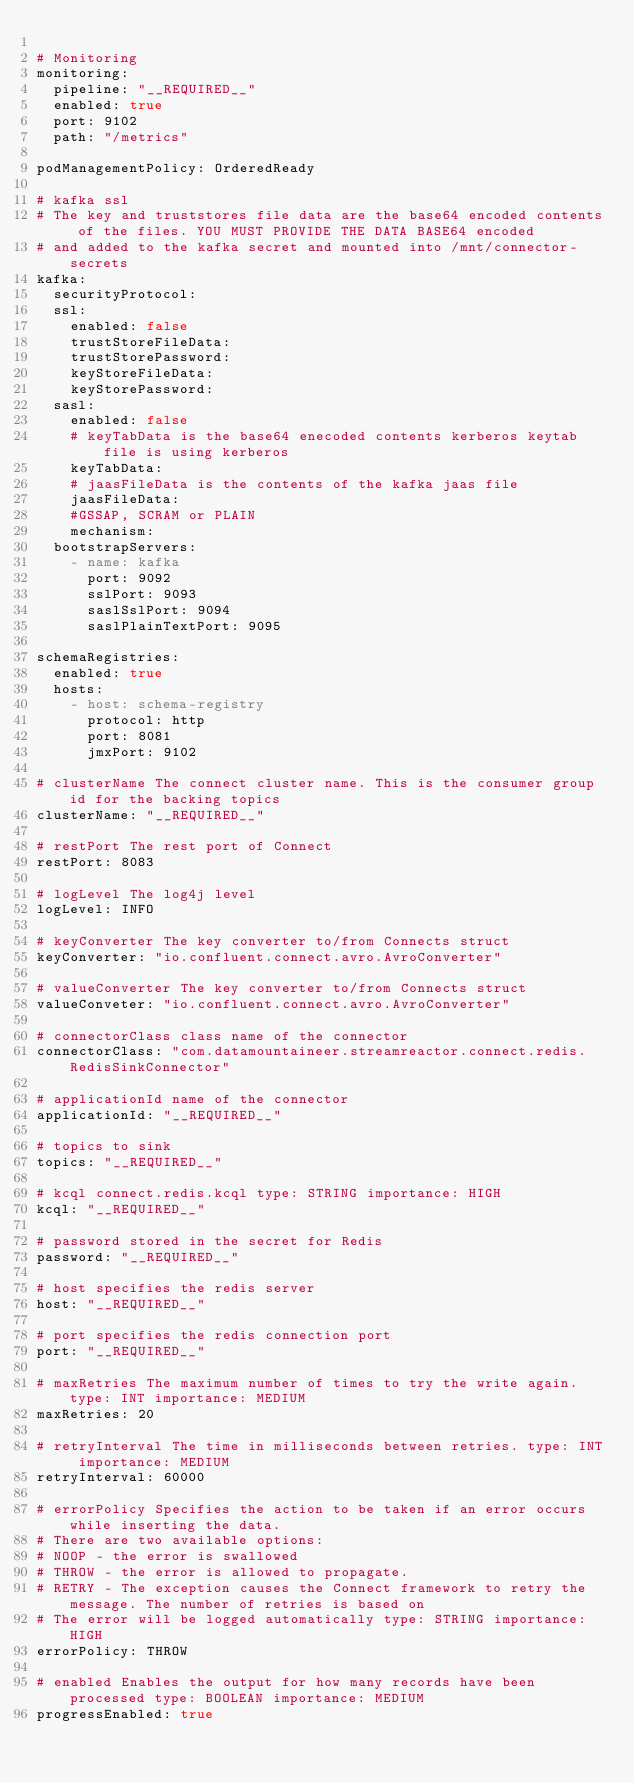<code> <loc_0><loc_0><loc_500><loc_500><_YAML_>
# Monitoring
monitoring:
  pipeline: "__REQUIRED__"
  enabled: true
  port: 9102
  path: "/metrics"

podManagementPolicy: OrderedReady

# kafka ssl
# The key and truststores file data are the base64 encoded contents of the files. YOU MUST PROVIDE THE DATA BASE64 encoded
# and added to the kafka secret and mounted into /mnt/connector-secrets
kafka:
  securityProtocol:
  ssl:
    enabled: false
    trustStoreFileData:
    trustStorePassword:
    keyStoreFileData:
    keyStorePassword:
  sasl:
    enabled: false
    # keyTabData is the base64 enecoded contents kerberos keytab file is using kerberos
    keyTabData:    
    # jaasFileData is the contents of the kafka jaas file
    jaasFileData: 
    #GSSAP, SCRAM or PLAIN
    mechanism: 
  bootstrapServers: 
    - name: kafka
      port: 9092
      sslPort: 9093
      saslSslPort: 9094
      saslPlainTextPort: 9095       

schemaRegistries:
  enabled: true
  hosts:
    - host: schema-registry
      protocol: http
      port: 8081
      jmxPort: 9102    

# clusterName The connect cluster name. This is the consumer group id for the backing topics
clusterName: "__REQUIRED__"

# restPort The rest port of Connect
restPort: 8083

# logLevel The log4j level
logLevel: INFO

# keyConverter The key converter to/from Connects struct
keyConverter: "io.confluent.connect.avro.AvroConverter"

# valueConverter The key converter to/from Connects struct
valueConveter: "io.confluent.connect.avro.AvroConverter"

# connectorClass class name of the connector
connectorClass: "com.datamountaineer.streamreactor.connect.redis.RedisSinkConnector"

# applicationId name of the connector
applicationId: "__REQUIRED__"

# topics to sink
topics: "__REQUIRED__"

# kcql connect.redis.kcql type: STRING importance: HIGH
kcql: "__REQUIRED__"

# password stored in the secret for Redis
password: "__REQUIRED__"

# host specifies the redis server
host: "__REQUIRED__"

# port specifies the redis connection port
port: "__REQUIRED__"

# maxRetries The maximum number of times to try the write again. type: INT importance: MEDIUM
maxRetries: 20

# retryInterval The time in milliseconds between retries. type: INT importance: MEDIUM
retryInterval: 60000

# errorPolicy Specifies the action to be taken if an error occurs while inserting the data.
# There are two available options:
# NOOP - the error is swallowed
# THROW - the error is allowed to propagate.
# RETRY - The exception causes the Connect framework to retry the message. The number of retries is based on
# The error will be logged automatically type: STRING importance: HIGH
errorPolicy: THROW

# enabled Enables the output for how many records have been processed type: BOOLEAN importance: MEDIUM
progressEnabled: true

</code> 